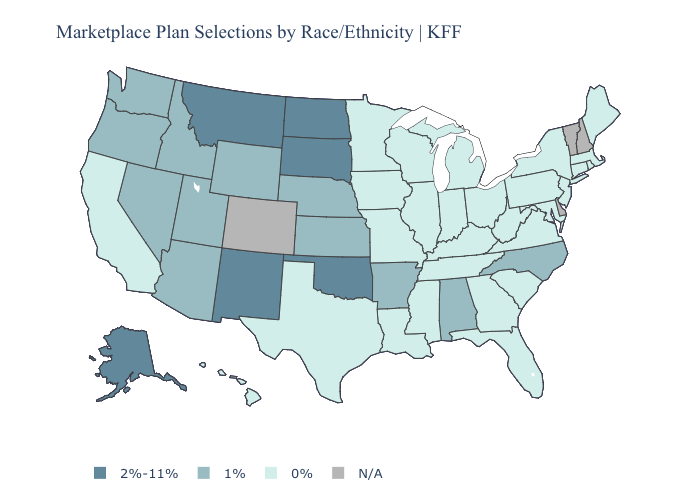Does Massachusetts have the highest value in the USA?
Keep it brief. No. Name the states that have a value in the range 2%-11%?
Concise answer only. Alaska, Montana, New Mexico, North Dakota, Oklahoma, South Dakota. Name the states that have a value in the range 0%?
Concise answer only. California, Connecticut, Florida, Georgia, Hawaii, Illinois, Indiana, Iowa, Kentucky, Louisiana, Maine, Maryland, Massachusetts, Michigan, Minnesota, Mississippi, Missouri, New Jersey, New York, Ohio, Pennsylvania, Rhode Island, South Carolina, Tennessee, Texas, Virginia, West Virginia, Wisconsin. Which states have the highest value in the USA?
Keep it brief. Alaska, Montana, New Mexico, North Dakota, Oklahoma, South Dakota. Among the states that border Massachusetts , which have the lowest value?
Concise answer only. Connecticut, New York, Rhode Island. Which states hav the highest value in the West?
Write a very short answer. Alaska, Montana, New Mexico. Which states hav the highest value in the MidWest?
Be succinct. North Dakota, South Dakota. What is the value of Pennsylvania?
Short answer required. 0%. What is the highest value in the Northeast ?
Write a very short answer. 0%. Among the states that border Idaho , which have the lowest value?
Quick response, please. Nevada, Oregon, Utah, Washington, Wyoming. Does Minnesota have the highest value in the USA?
Quick response, please. No. What is the value of Texas?
Concise answer only. 0%. How many symbols are there in the legend?
Answer briefly. 4. What is the value of New Hampshire?
Give a very brief answer. N/A. 